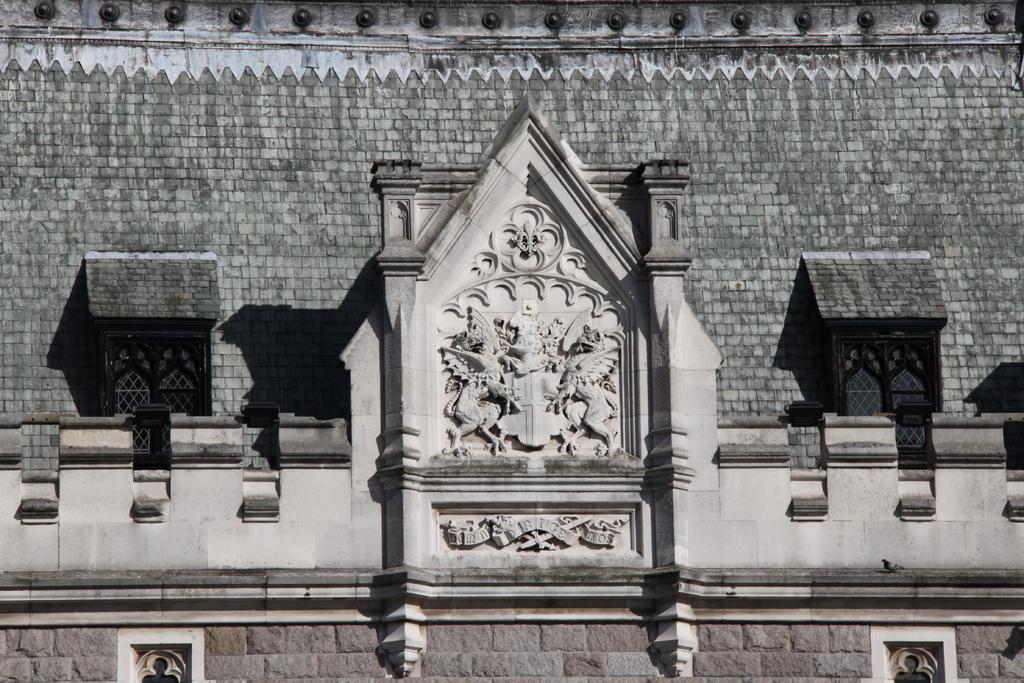Could you give a brief overview of what you see in this image? In this image I can see the building. I can see some statues to the building. I can see the building is in grey and ash color. 